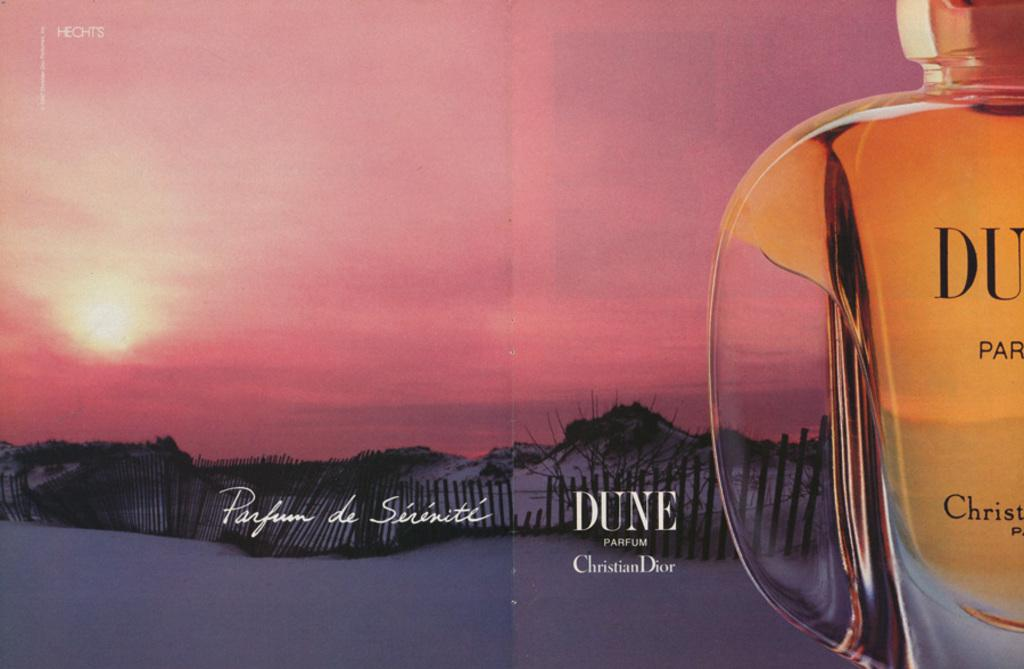<image>
Give a short and clear explanation of the subsequent image. A magazine ad for Dune by Chiristian Dior Parfum. 